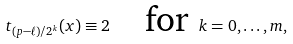<formula> <loc_0><loc_0><loc_500><loc_500>t _ { ( p - \ell ) / 2 ^ { k } } ( x ) \equiv 2 \text {\quad for } k = 0 , \dots , m ,</formula> 